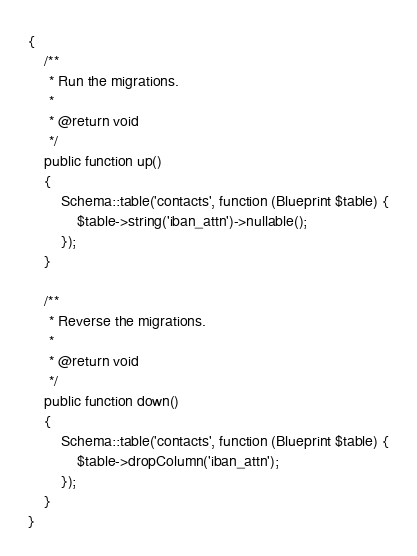Convert code to text. <code><loc_0><loc_0><loc_500><loc_500><_PHP_>{
    /**
     * Run the migrations.
     *
     * @return void
     */
    public function up()
    {
        Schema::table('contacts', function (Blueprint $table) {
            $table->string('iban_attn')->nullable();
        });
    }

    /**
     * Reverse the migrations.
     *
     * @return void
     */
    public function down()
    {
        Schema::table('contacts', function (Blueprint $table) {
            $table->dropColumn('iban_attn');
        });
    }
}
</code> 